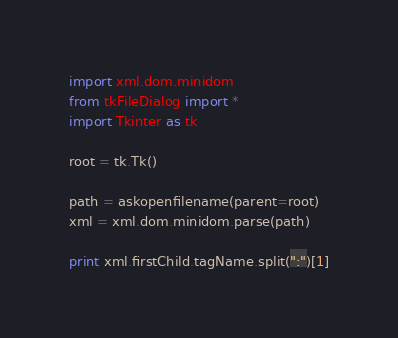Convert code to text. <code><loc_0><loc_0><loc_500><loc_500><_Python_>import xml.dom.minidom
from tkFileDialog import *
import Tkinter as tk

root = tk.Tk()

path = askopenfilename(parent=root)
xml = xml.dom.minidom.parse(path)

print xml.firstChild.tagName.split(":")[1]</code> 